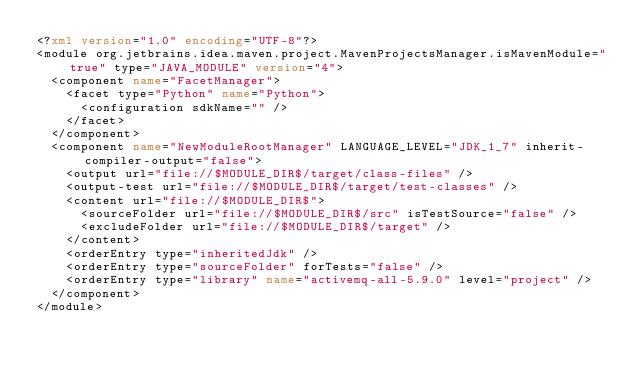<code> <loc_0><loc_0><loc_500><loc_500><_XML_><?xml version="1.0" encoding="UTF-8"?>
<module org.jetbrains.idea.maven.project.MavenProjectsManager.isMavenModule="true" type="JAVA_MODULE" version="4">
  <component name="FacetManager">
    <facet type="Python" name="Python">
      <configuration sdkName="" />
    </facet>
  </component>
  <component name="NewModuleRootManager" LANGUAGE_LEVEL="JDK_1_7" inherit-compiler-output="false">
    <output url="file://$MODULE_DIR$/target/class-files" />
    <output-test url="file://$MODULE_DIR$/target/test-classes" />
    <content url="file://$MODULE_DIR$">
      <sourceFolder url="file://$MODULE_DIR$/src" isTestSource="false" />
      <excludeFolder url="file://$MODULE_DIR$/target" />
    </content>
    <orderEntry type="inheritedJdk" />
    <orderEntry type="sourceFolder" forTests="false" />
    <orderEntry type="library" name="activemq-all-5.9.0" level="project" />
  </component>
</module></code> 